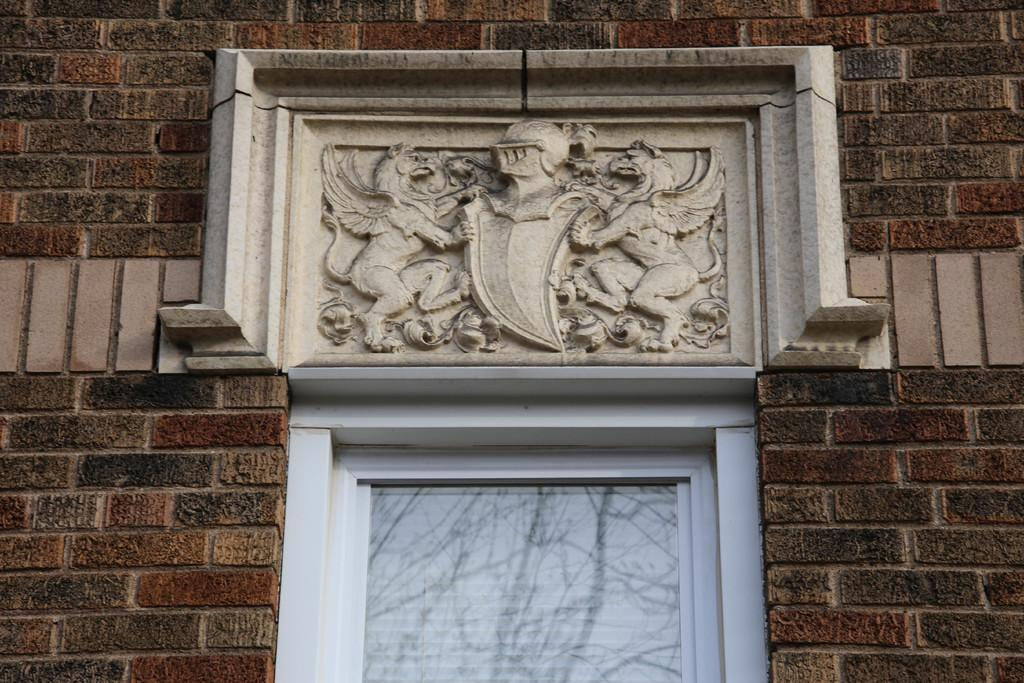What type of structure is visible in the image? There is a brick wall in the image. What is attached to the brick wall? The brick wall has a carved marble plate. Can you describe the window in the image? There is a window at the bottom of the image. What type of bulb is used to light up the marble plate in the image? There is no bulb present in the image; the marble plate is carved and not illuminated. 